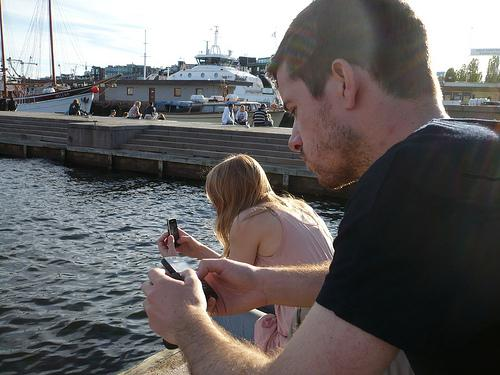Question: what is in front of the people?
Choices:
A. Table.
B. Chairs.
C. Water.
D. Food.
Answer with the letter. Answer: C Question: what color is the water?
Choices:
A. Brown.
B. Gray.
C. Green.
D. Blue.
Answer with the letter. Answer: B Question: what are in the people's hands?
Choices:
A. Cell phones.
B. Flowers.
C. Keys.
D. Hats.
Answer with the letter. Answer: A Question: what color is the man's shirt?
Choices:
A. Blue.
B. Black.
C. White.
D. Brown.
Answer with the letter. Answer: B Question: where are the people sitting?
Choices:
A. Outside.
B. Dock.
C. Table.
D. On patio.
Answer with the letter. Answer: B Question: what color is the girl's shirt?
Choices:
A. White.
B. Pink.
C. Green.
D. Blue.
Answer with the letter. Answer: B 